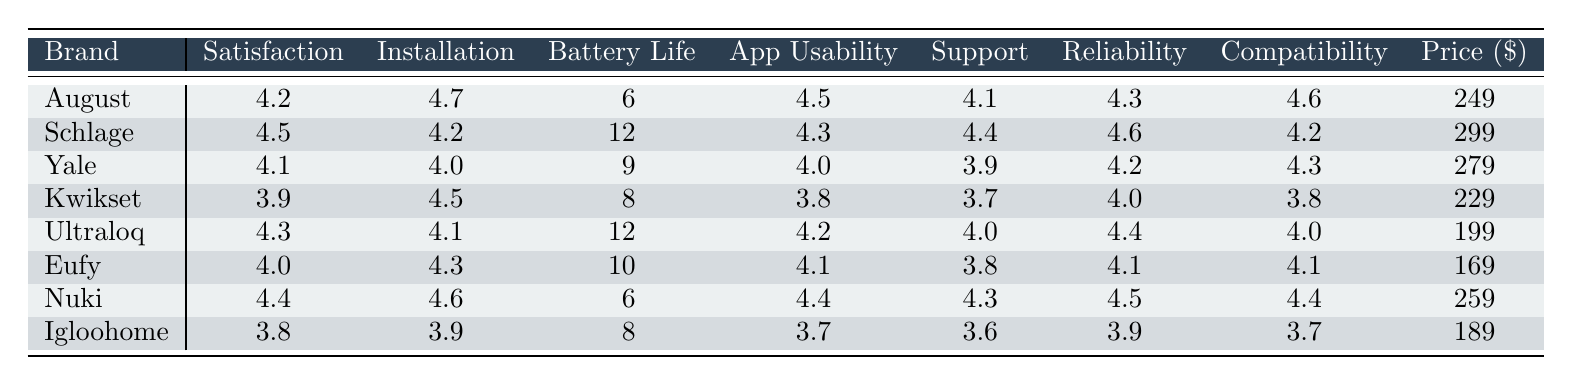What is the highest satisfaction rating among the brands? The table lists satisfaction ratings for each brand. By reviewing the values, I see that Schlage has the highest rating of 4.5.
Answer: 4.5 Which brand has the easiest installation according to the ratings? The installation ratings are provided for each brand. Among these, August has the highest installation rating of 4.7.
Answer: August What is the average battery life for the smart locks? To find the average battery life, I sum the battery life values (6 + 12 + 9 + 8 + 12 + 10 + 6 + 8) = 71, and divide by the number of brands (8): 71/8 = 8.875.
Answer: 8.9 months Is the customer support rating for Eufy higher than that of Igloohome? Eufy's customer support rating is 3.8, while Igloohome's rating is 3.6. Since 3.8 is greater than 3.6, the statement is true.
Answer: Yes Which brand has the highest average price, and what is that price? A review of the price column shows Schlage has the highest price at $299.
Answer: Schlage, $299 What is the median satisfaction rating among the brands? Arranging the satisfaction ratings in order (3.8, 3.9, 4.1, 4.2, 4.3, 4.4, 4.5), the median is the average of the two middle values (4.2 + 4.3) / 2 = 4.25.
Answer: 4.25 Is there a brand that has both a high battery life (above 10 months) and a high satisfaction rating (above 4.0)? The brands with battery lives above 10 months are Schlage (12) and Ultraloq (12). Both have satisfaction ratings of 4.5 and 4.3 respectively, which are above 4.0. Therefore, both brands meet the criteria.
Answer: Yes What is the difference in reliability ratings between Kwikset and Nuki? Kwikset has a reliability rating of 4.0 and Nuki has a rating of 4.5. The difference is 4.5 - 4.0 = 0.5.
Answer: 0.5 What brand offers the best combination of installation ease (over 4.5) and customer support (over 4.0)? I look for brands with installation ratings above 4.5 and customer support ratings above 4.0. August (4.7, 4.1) and Nuki (4.6, 4.3) fit the criteria, but August has a lower customer support rating than Nuki. Therefore, Nuki offers the best combination.
Answer: Nuki How does the compatibility rating of Igloohome compare to that of August? Igloohome has a compatibility rating of 3.7 while August has a rating of 4.6. Comparing these, 4.6 is higher than 3.7.
Answer: August is higher 